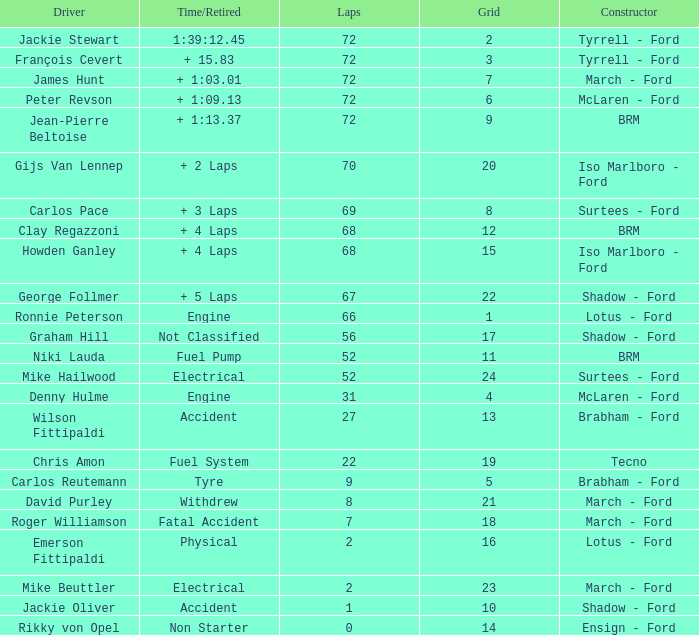Could you parse the entire table? {'header': ['Driver', 'Time/Retired', 'Laps', 'Grid', 'Constructor'], 'rows': [['Jackie Stewart', '1:39:12.45', '72', '2', 'Tyrrell - Ford'], ['François Cevert', '+ 15.83', '72', '3', 'Tyrrell - Ford'], ['James Hunt', '+ 1:03.01', '72', '7', 'March - Ford'], ['Peter Revson', '+ 1:09.13', '72', '6', 'McLaren - Ford'], ['Jean-Pierre Beltoise', '+ 1:13.37', '72', '9', 'BRM'], ['Gijs Van Lennep', '+ 2 Laps', '70', '20', 'Iso Marlboro - Ford'], ['Carlos Pace', '+ 3 Laps', '69', '8', 'Surtees - Ford'], ['Clay Regazzoni', '+ 4 Laps', '68', '12', 'BRM'], ['Howden Ganley', '+ 4 Laps', '68', '15', 'Iso Marlboro - Ford'], ['George Follmer', '+ 5 Laps', '67', '22', 'Shadow - Ford'], ['Ronnie Peterson', 'Engine', '66', '1', 'Lotus - Ford'], ['Graham Hill', 'Not Classified', '56', '17', 'Shadow - Ford'], ['Niki Lauda', 'Fuel Pump', '52', '11', 'BRM'], ['Mike Hailwood', 'Electrical', '52', '24', 'Surtees - Ford'], ['Denny Hulme', 'Engine', '31', '4', 'McLaren - Ford'], ['Wilson Fittipaldi', 'Accident', '27', '13', 'Brabham - Ford'], ['Chris Amon', 'Fuel System', '22', '19', 'Tecno'], ['Carlos Reutemann', 'Tyre', '9', '5', 'Brabham - Ford'], ['David Purley', 'Withdrew', '8', '21', 'March - Ford'], ['Roger Williamson', 'Fatal Accident', '7', '18', 'March - Ford'], ['Emerson Fittipaldi', 'Physical', '2', '16', 'Lotus - Ford'], ['Mike Beuttler', 'Electrical', '2', '23', 'March - Ford'], ['Jackie Oliver', 'Accident', '1', '10', 'Shadow - Ford'], ['Rikky von Opel', 'Non Starter', '0', '14', 'Ensign - Ford']]} What is the top grid that roger williamson lapped less than 7? None. 